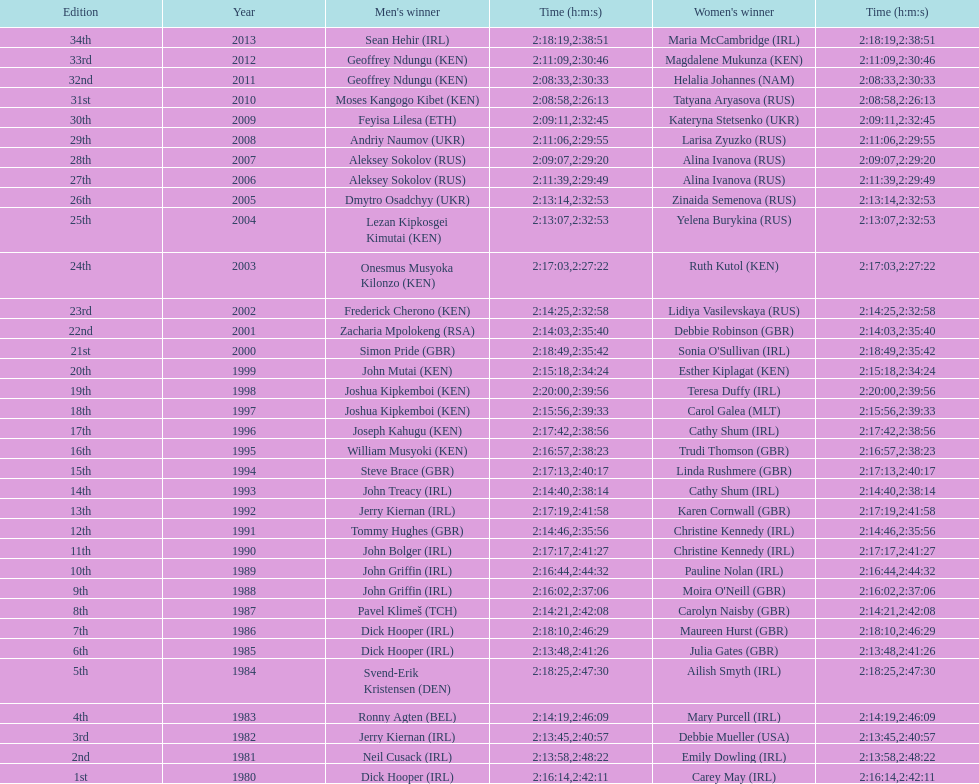How many women's winners are from kenya? 3. 